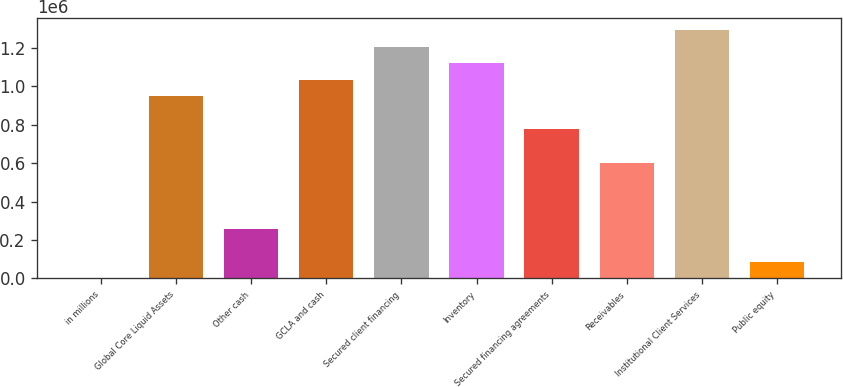<chart> <loc_0><loc_0><loc_500><loc_500><bar_chart><fcel>in millions<fcel>Global Core Liquid Assets<fcel>Other cash<fcel>GCLA and cash<fcel>Secured client financing<fcel>Inventory<fcel>Secured financing agreements<fcel>Receivables<fcel>Institutional Client Services<fcel>Public equity<nl><fcel>2015<fcel>947333<fcel>259829<fcel>1.03327e+06<fcel>1.20515e+06<fcel>1.11921e+06<fcel>775457<fcel>603581<fcel>1.29108e+06<fcel>87953<nl></chart> 